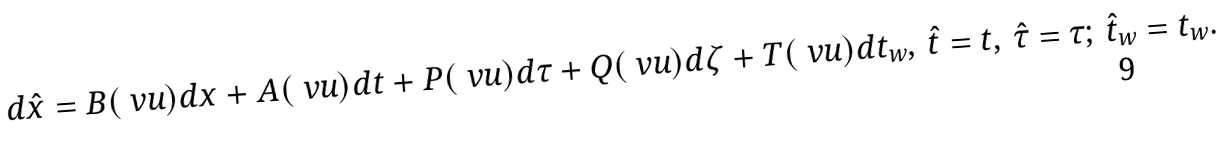Convert formula to latex. <formula><loc_0><loc_0><loc_500><loc_500>d { \hat { x } } = B ( \ v u ) d x + A ( \ v u ) d t + P ( \ v u ) d \tau + Q ( \ v u ) d \zeta + T ( \ v u ) d t _ { w } , \, { \hat { t } } = t , \, { \hat { \tau } } = \tau ; \, { \hat { t } } _ { w } = t _ { w } .</formula> 